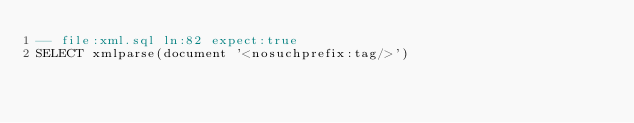Convert code to text. <code><loc_0><loc_0><loc_500><loc_500><_SQL_>-- file:xml.sql ln:82 expect:true
SELECT xmlparse(document '<nosuchprefix:tag/>')
</code> 